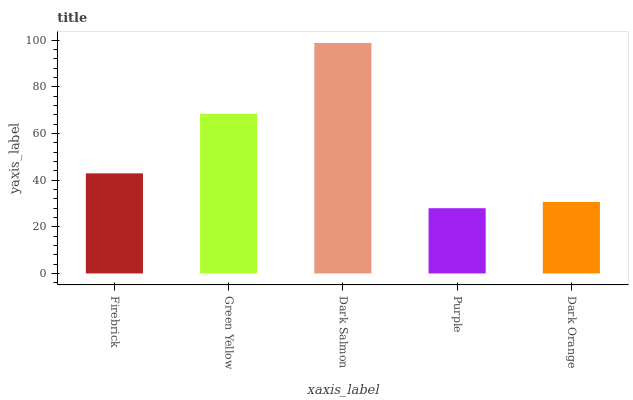Is Purple the minimum?
Answer yes or no. Yes. Is Dark Salmon the maximum?
Answer yes or no. Yes. Is Green Yellow the minimum?
Answer yes or no. No. Is Green Yellow the maximum?
Answer yes or no. No. Is Green Yellow greater than Firebrick?
Answer yes or no. Yes. Is Firebrick less than Green Yellow?
Answer yes or no. Yes. Is Firebrick greater than Green Yellow?
Answer yes or no. No. Is Green Yellow less than Firebrick?
Answer yes or no. No. Is Firebrick the high median?
Answer yes or no. Yes. Is Firebrick the low median?
Answer yes or no. Yes. Is Purple the high median?
Answer yes or no. No. Is Dark Orange the low median?
Answer yes or no. No. 